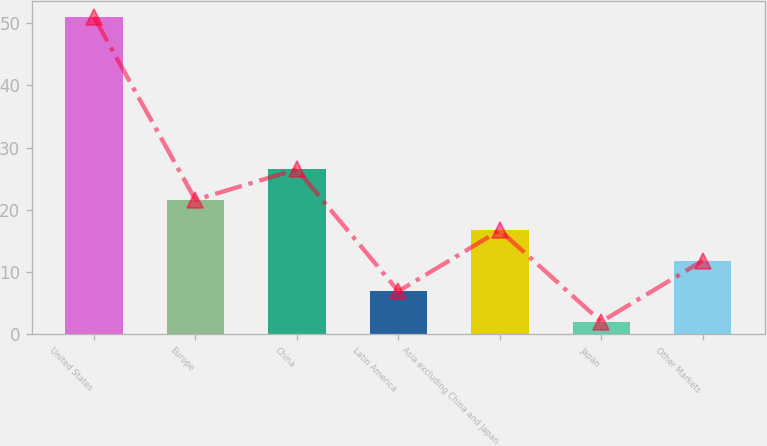<chart> <loc_0><loc_0><loc_500><loc_500><bar_chart><fcel>United States<fcel>Europe<fcel>China<fcel>Latin America<fcel>Asia excluding China and Japan<fcel>Japan<fcel>Other Markets<nl><fcel>51<fcel>21.6<fcel>26.5<fcel>6.9<fcel>16.7<fcel>2<fcel>11.8<nl></chart> 